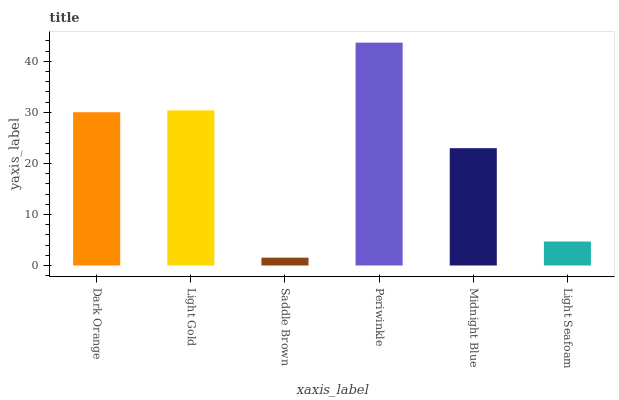Is Saddle Brown the minimum?
Answer yes or no. Yes. Is Periwinkle the maximum?
Answer yes or no. Yes. Is Light Gold the minimum?
Answer yes or no. No. Is Light Gold the maximum?
Answer yes or no. No. Is Light Gold greater than Dark Orange?
Answer yes or no. Yes. Is Dark Orange less than Light Gold?
Answer yes or no. Yes. Is Dark Orange greater than Light Gold?
Answer yes or no. No. Is Light Gold less than Dark Orange?
Answer yes or no. No. Is Dark Orange the high median?
Answer yes or no. Yes. Is Midnight Blue the low median?
Answer yes or no. Yes. Is Periwinkle the high median?
Answer yes or no. No. Is Light Seafoam the low median?
Answer yes or no. No. 